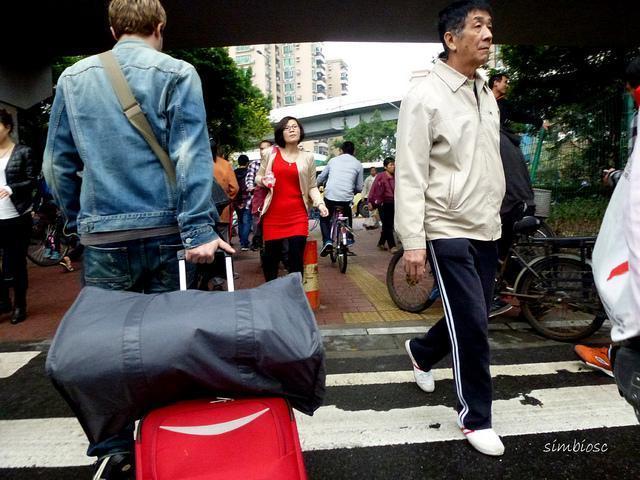How many people are there?
Give a very brief answer. 7. How many orange cups are on the table?
Give a very brief answer. 0. 